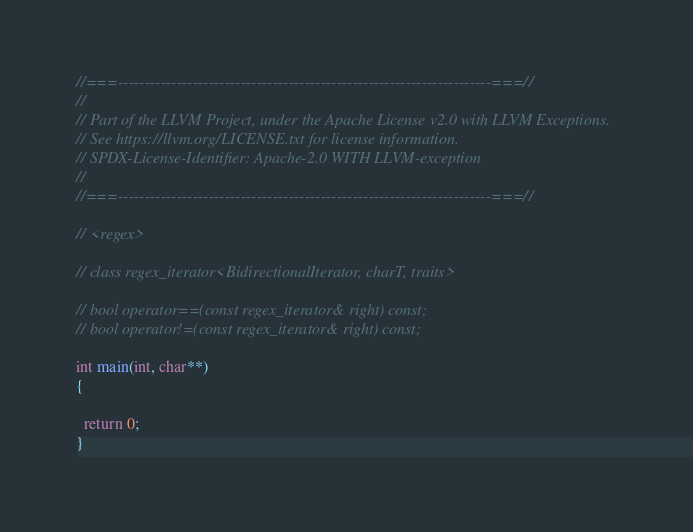<code> <loc_0><loc_0><loc_500><loc_500><_C++_>//===----------------------------------------------------------------------===//
//
// Part of the LLVM Project, under the Apache License v2.0 with LLVM Exceptions.
// See https://llvm.org/LICENSE.txt for license information.
// SPDX-License-Identifier: Apache-2.0 WITH LLVM-exception
//
//===----------------------------------------------------------------------===//

// <regex>

// class regex_iterator<BidirectionalIterator, charT, traits>

// bool operator==(const regex_iterator& right) const;
// bool operator!=(const regex_iterator& right) const;

int main(int, char**)
{

  return 0;
}
</code> 